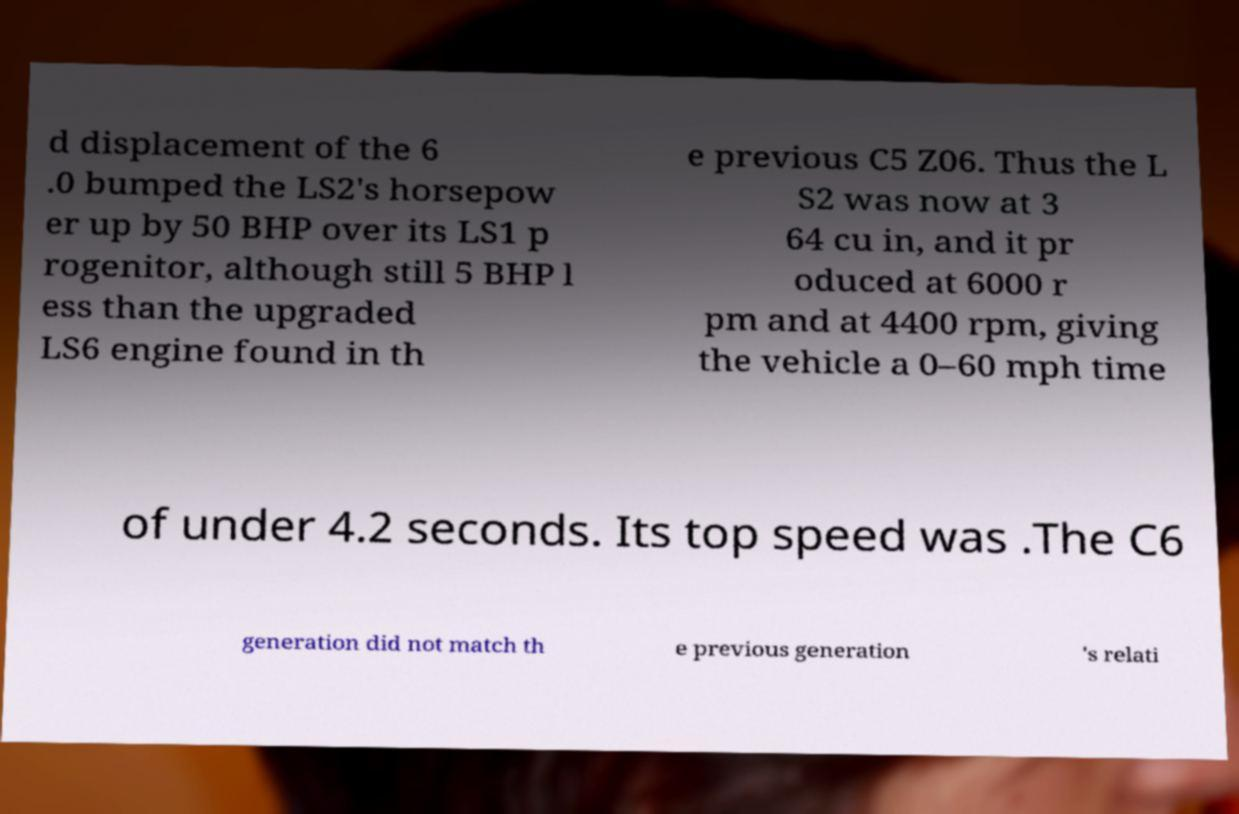For documentation purposes, I need the text within this image transcribed. Could you provide that? d displacement of the 6 .0 bumped the LS2's horsepow er up by 50 BHP over its LS1 p rogenitor, although still 5 BHP l ess than the upgraded LS6 engine found in th e previous C5 Z06. Thus the L S2 was now at 3 64 cu in, and it pr oduced at 6000 r pm and at 4400 rpm, giving the vehicle a 0–60 mph time of under 4.2 seconds. Its top speed was .The C6 generation did not match th e previous generation 's relati 